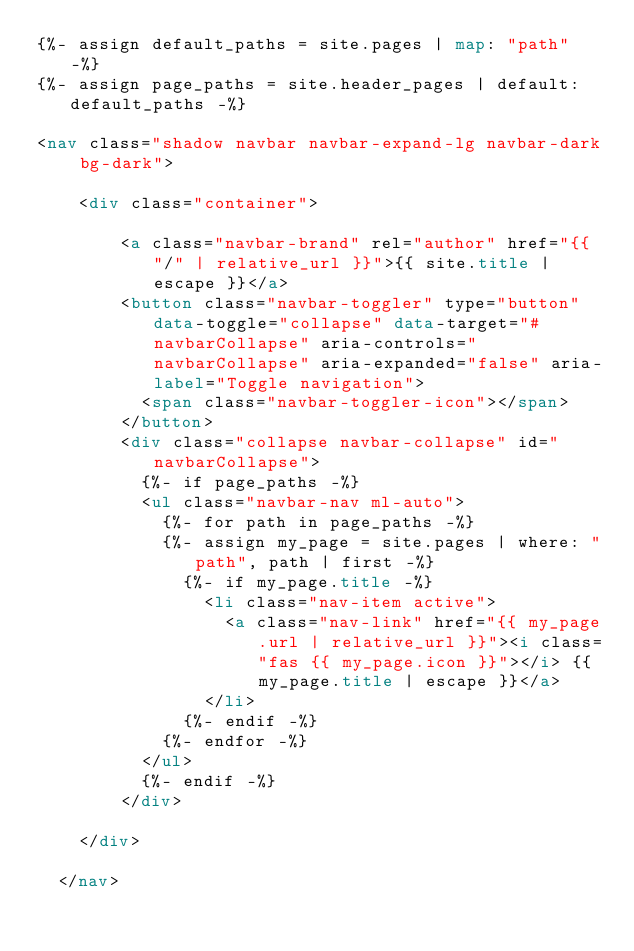<code> <loc_0><loc_0><loc_500><loc_500><_HTML_>{%- assign default_paths = site.pages | map: "path" -%}
{%- assign page_paths = site.header_pages | default: default_paths -%}

<nav class="shadow navbar navbar-expand-lg navbar-dark bg-dark">

    <div class="container">

        <a class="navbar-brand" rel="author" href="{{ "/" | relative_url }}">{{ site.title | escape }}</a>
        <button class="navbar-toggler" type="button" data-toggle="collapse" data-target="#navbarCollapse" aria-controls="navbarCollapse" aria-expanded="false" aria-label="Toggle navigation">
          <span class="navbar-toggler-icon"></span>
        </button>
        <div class="collapse navbar-collapse" id="navbarCollapse">
          {%- if page_paths -%}
          <ul class="navbar-nav ml-auto">
            {%- for path in page_paths -%}
            {%- assign my_page = site.pages | where: "path", path | first -%}
              {%- if my_page.title -%}
                <li class="nav-item active">
                  <a class="nav-link" href="{{ my_page.url | relative_url }}"><i class="fas {{ my_page.icon }}"></i> {{ my_page.title | escape }}</a>
                </li>
              {%- endif -%}
            {%- endfor -%}  
          </ul>
          {%- endif -%} 
        </div>

    </div>
    
  </nav>
</code> 